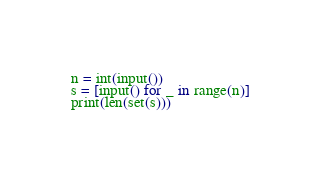<code> <loc_0><loc_0><loc_500><loc_500><_Python_>n = int(input())
s = [input() for _ in range(n)]
print(len(set(s)))</code> 